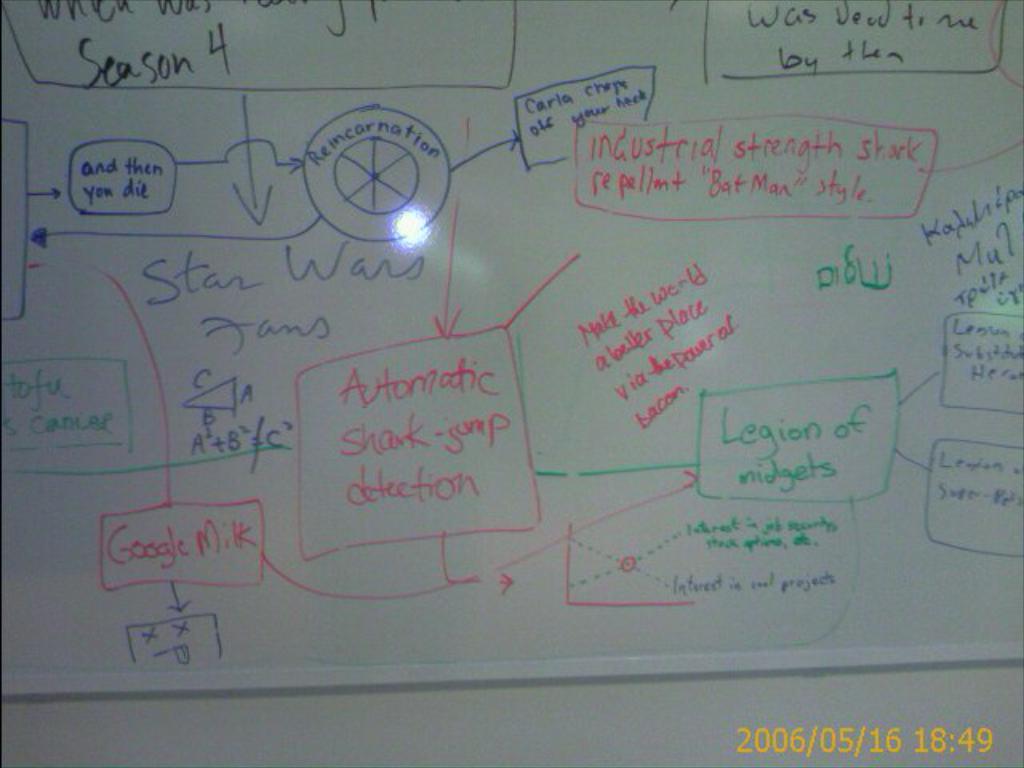What season is it for the show?
Keep it short and to the point. 4. 